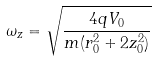Convert formula to latex. <formula><loc_0><loc_0><loc_500><loc_500>\omega _ { z } = \sqrt { \frac { 4 q V _ { 0 } } { m ( r _ { 0 } ^ { 2 } + 2 z _ { 0 } ^ { 2 } ) } }</formula> 